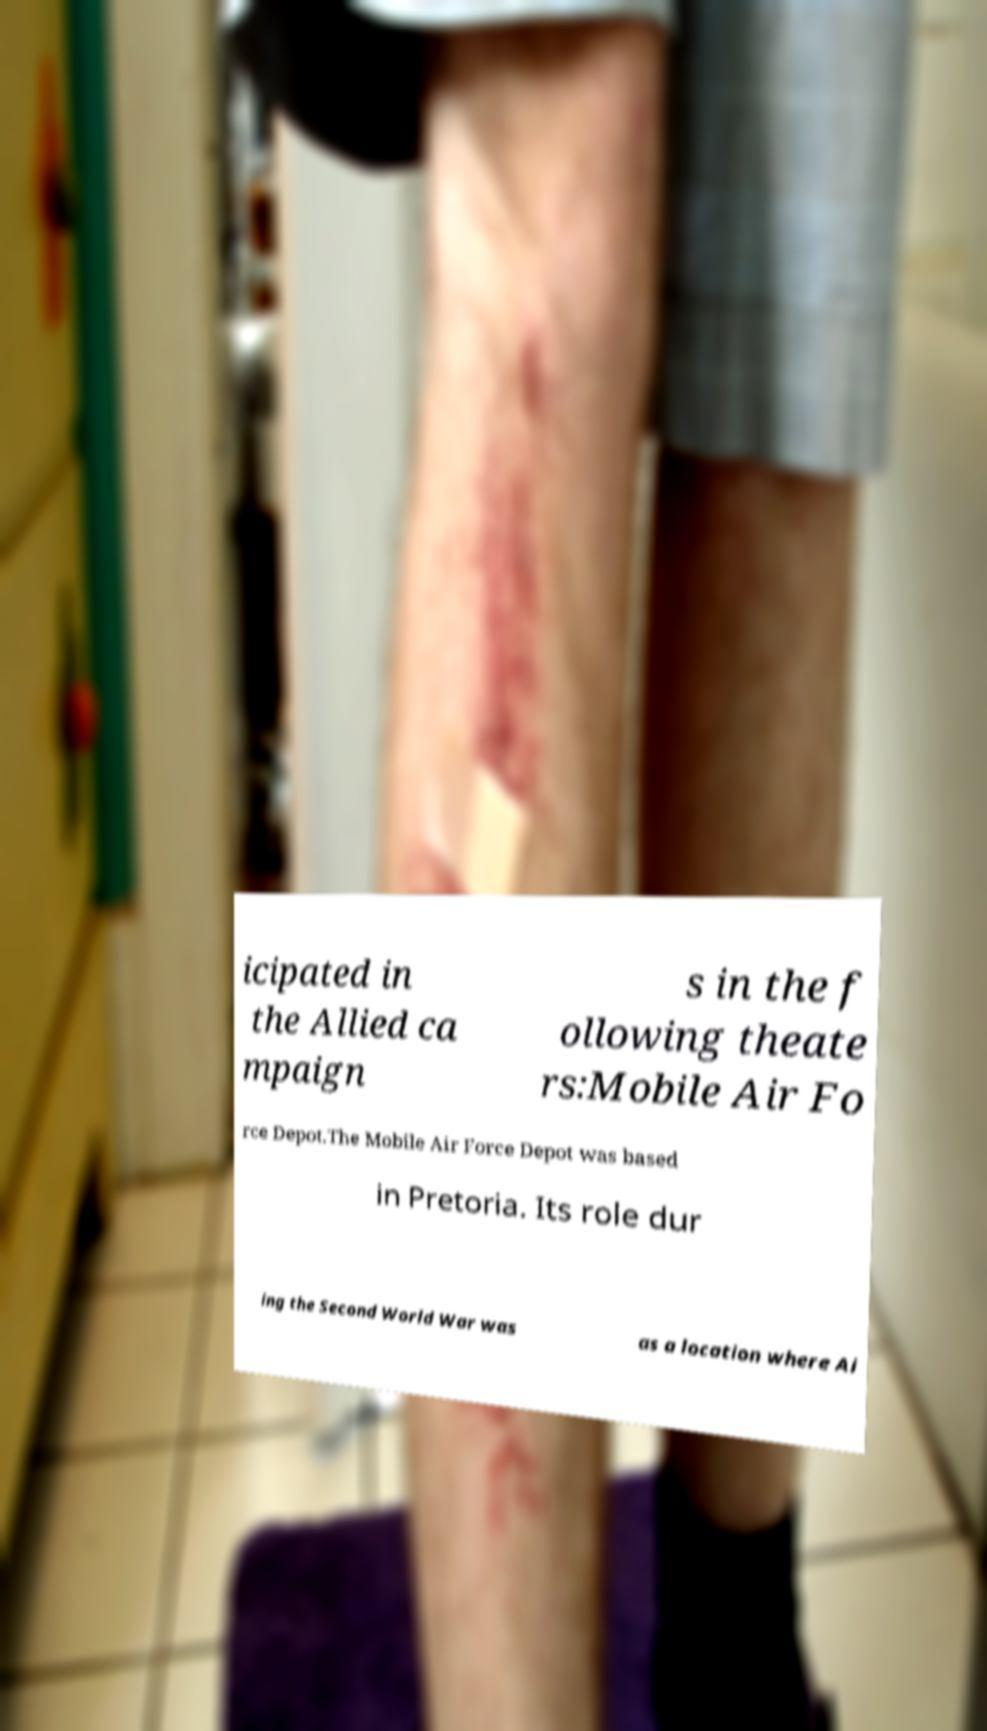Please identify and transcribe the text found in this image. icipated in the Allied ca mpaign s in the f ollowing theate rs:Mobile Air Fo rce Depot.The Mobile Air Force Depot was based in Pretoria. Its role dur ing the Second World War was as a location where Ai 